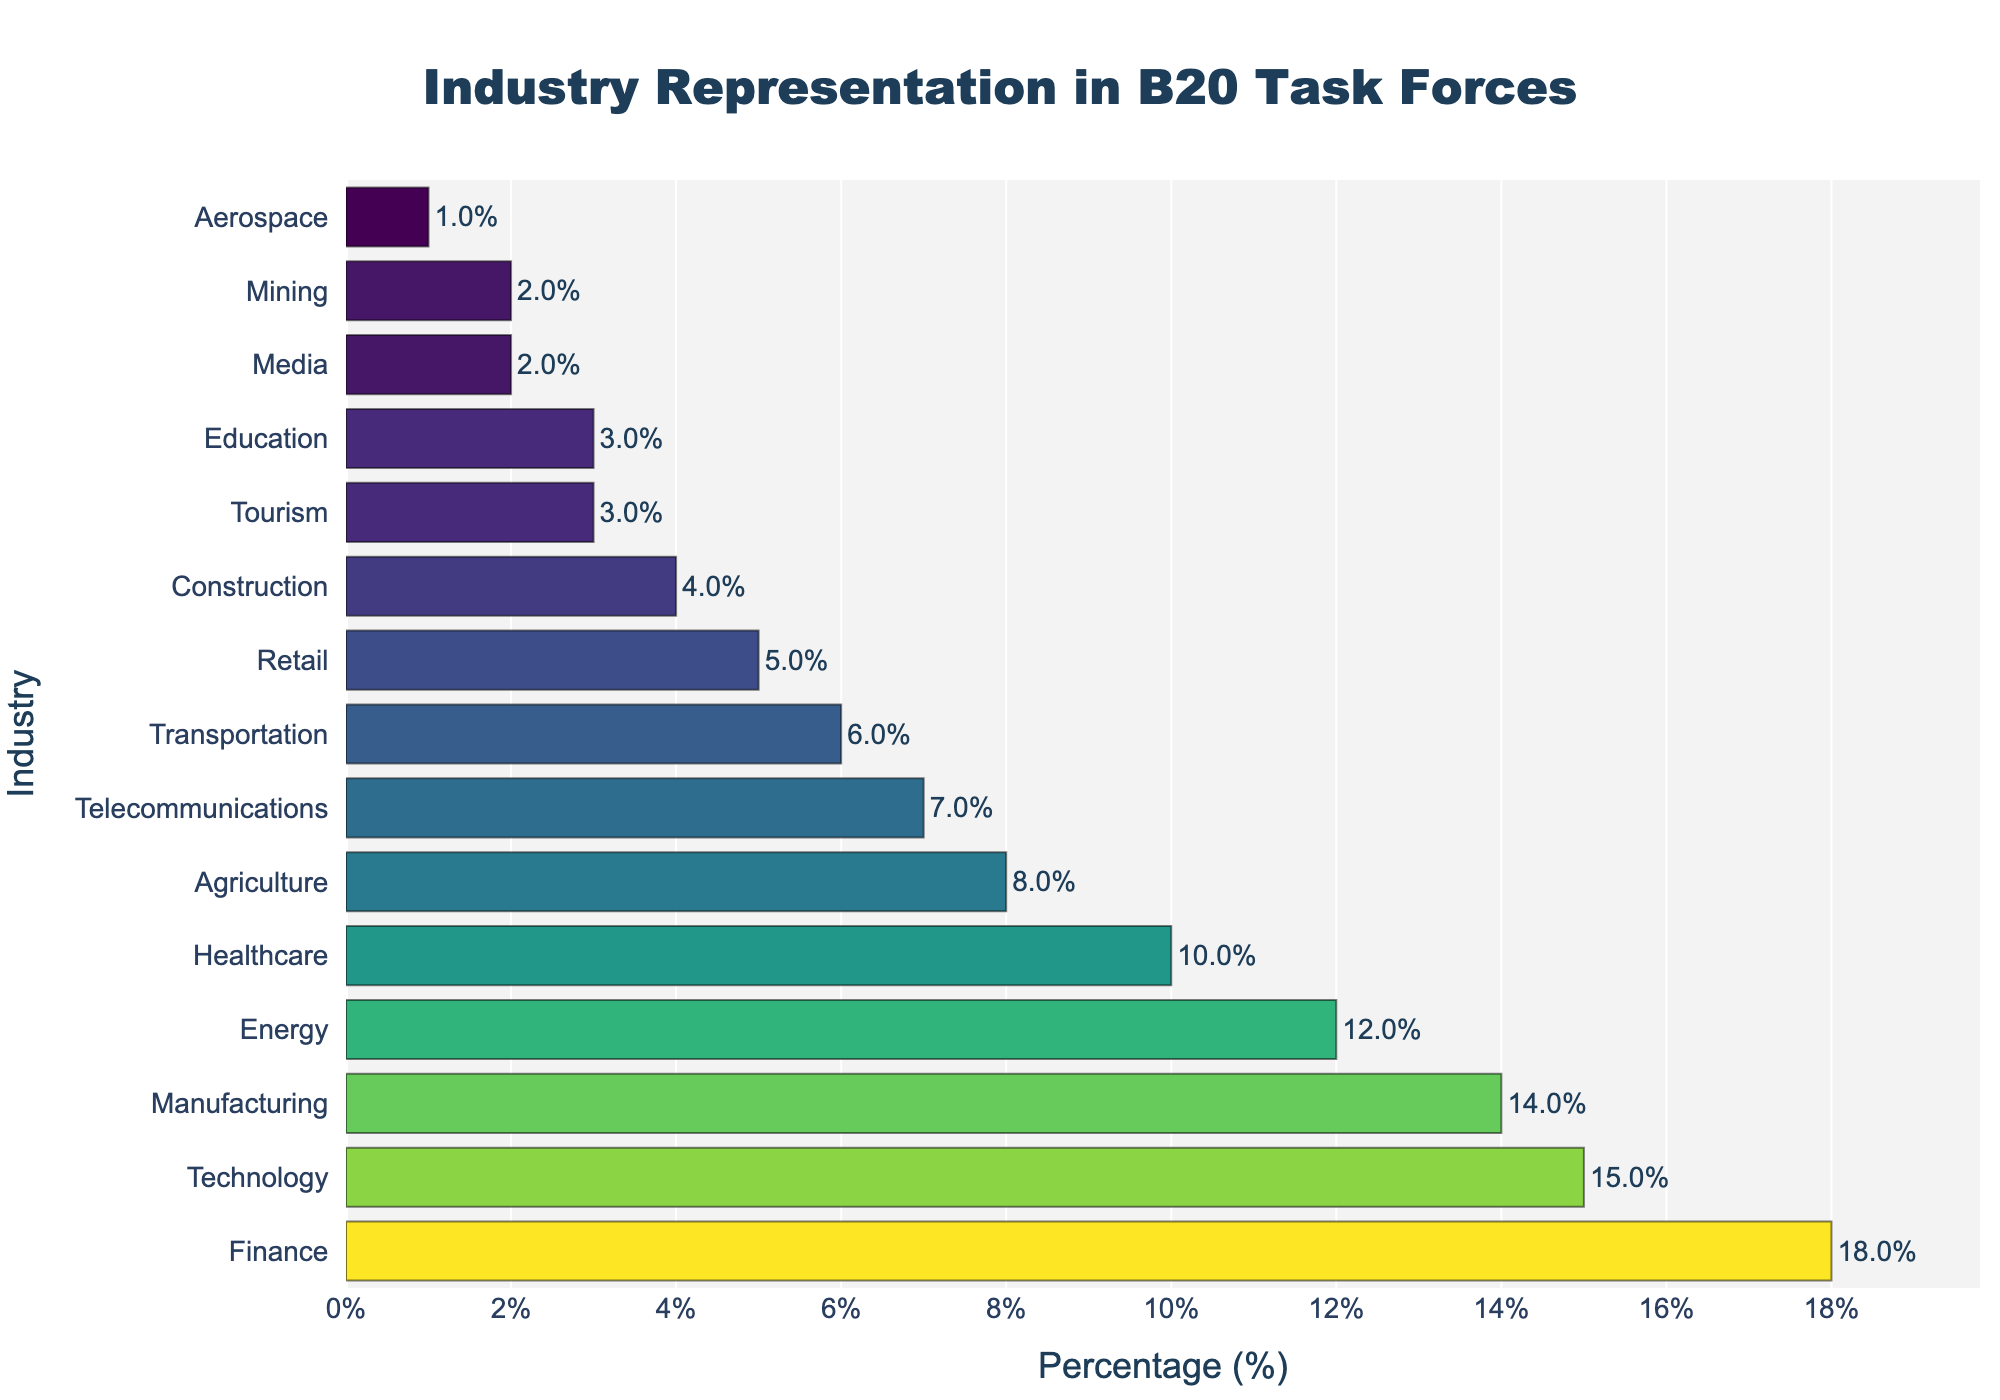Which industry has the highest representation in B20 Task Forces? The Finance industry has the highest bar in the chart, indicating it has the highest percentage.
Answer: Finance What is the combined percentage of the top three industries? The percentages for Finance, Technology, and Manufacturing are 18%, 15%, and 14% respectively. The combined percentage is 18 + 15 + 14 = 47%.
Answer: 47% Which industry is least represented in B20 Task Forces, and what is its percentage share? The Aerospace industry has the smallest bar, indicating it is the least represented with a percentage share of 1%.
Answer: Aerospace, 1% How does the representation of the Healthcare industry compare to the Energy industry? The Healthcare industry has a bar indicating 10%, while the Energy industry has a bar indicating 12%. Therefore, Healthcare has a 2% lower representation.
Answer: Healthcare is 2% less than Energy What is the average representation percentage of the Agriculture, Telecommunications, and Transportation industries? The percentages for Agriculture, Telecommunications, and Transportation are 8%, 7%, and 6% respectively. The average is (8 + 7 + 6) / 3 = 7%.
Answer: 7% Which industries have a representation of 5% or less? The bars for Retail, Construction, Tourism, Education, Media, Mining, and Aerospace all fall at or below the 5% mark.
Answer: Retail, Construction, Tourism, Education, Media, Mining, Aerospace Is the representation of the Technology industry greater than that of the Manufacturing industry? By how much? The bar for Technology shows 15%, while the bar for Manufacturing shows 14%. Technology is 1% greater than Manufacturing.
Answer: Yes, by 1% What is the total percentage representation of industries other than Finance, Technology, and Manufacturing? The total percentage representation is 100%. Subtracting the top three industries (18% + 15% + 14% = 47%), the remaining percentage is 100 - 47 = 53%.
Answer: 53% Compared to Telecommunications, does the Agriculture industry have a higher or lower percentage? The Agriculture industry has 8%, whereas Telecommunications has 7%. Thus, Agriculture has a higher percentage.
Answer: Higher What is the range of the percentages shown in the chart? The highest percentage is 18% (Finance) and the lowest is 1% (Aerospace). The range is 18 - 1 = 17%.
Answer: 17% 